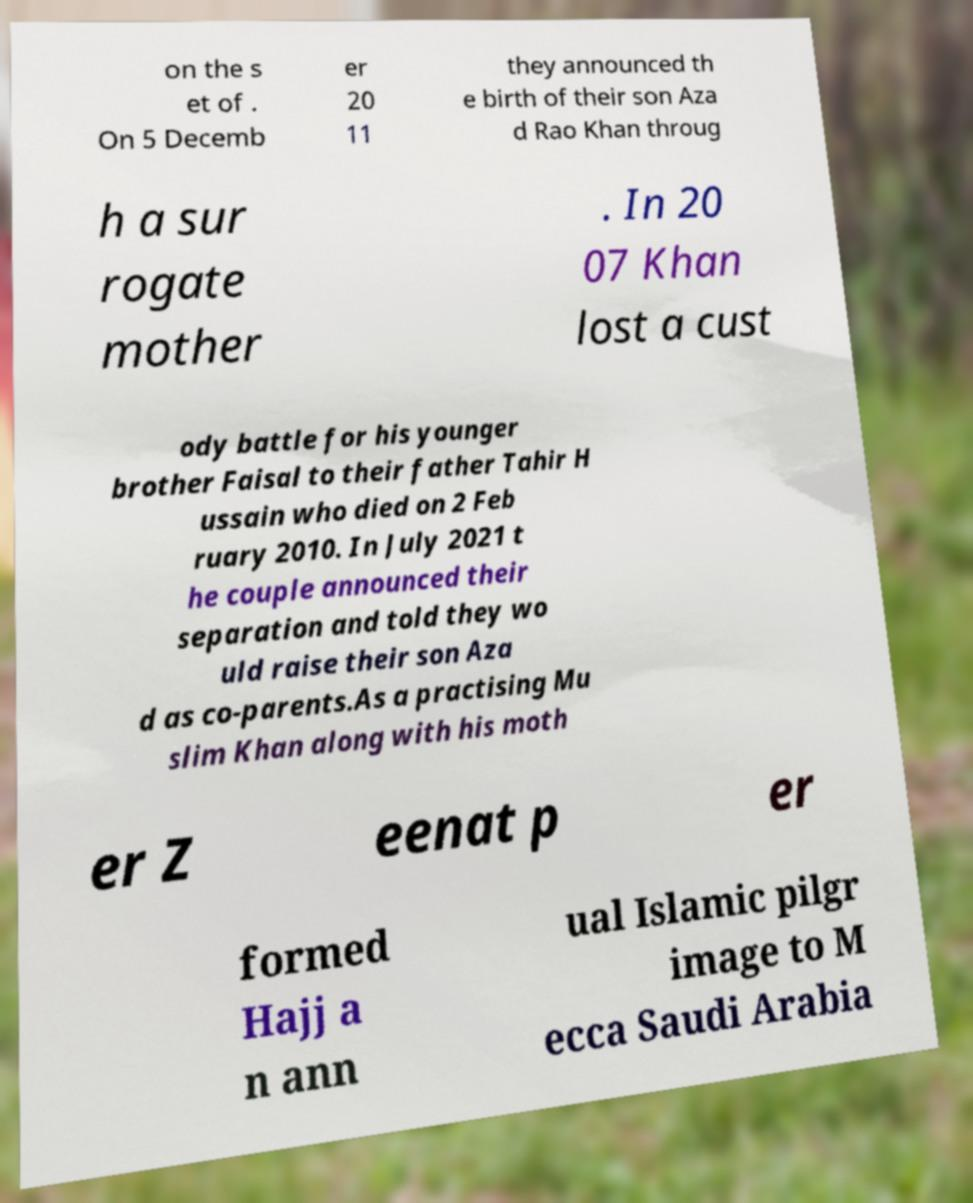Can you read and provide the text displayed in the image?This photo seems to have some interesting text. Can you extract and type it out for me? on the s et of . On 5 Decemb er 20 11 they announced th e birth of their son Aza d Rao Khan throug h a sur rogate mother . In 20 07 Khan lost a cust ody battle for his younger brother Faisal to their father Tahir H ussain who died on 2 Feb ruary 2010. In July 2021 t he couple announced their separation and told they wo uld raise their son Aza d as co-parents.As a practising Mu slim Khan along with his moth er Z eenat p er formed Hajj a n ann ual Islamic pilgr image to M ecca Saudi Arabia 